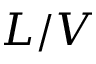<formula> <loc_0><loc_0><loc_500><loc_500>L / V</formula> 